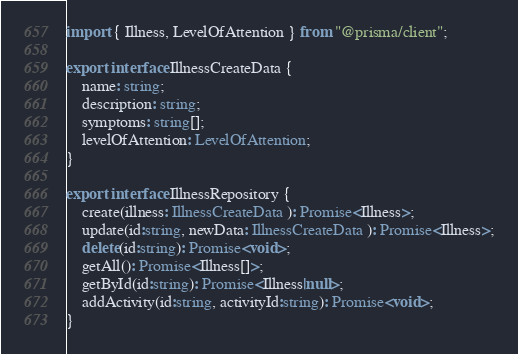<code> <loc_0><loc_0><loc_500><loc_500><_TypeScript_>import { Illness, LevelOfAttention } from "@prisma/client";

export interface IllnessCreateData {
    name: string;
    description: string;
    symptoms: string[];
    levelOfAttention: LevelOfAttention;
}

export interface IllnessRepository {
    create(illness: IllnessCreateData ): Promise<Illness>;
    update(id:string, newData: IllnessCreateData ): Promise<Illness>;
    delete(id:string): Promise<void>;
    getAll(): Promise<Illness[]>;
    getById(id:string): Promise<Illness|null>;
    addActivity(id:string, activityId:string): Promise<void>;
}</code> 